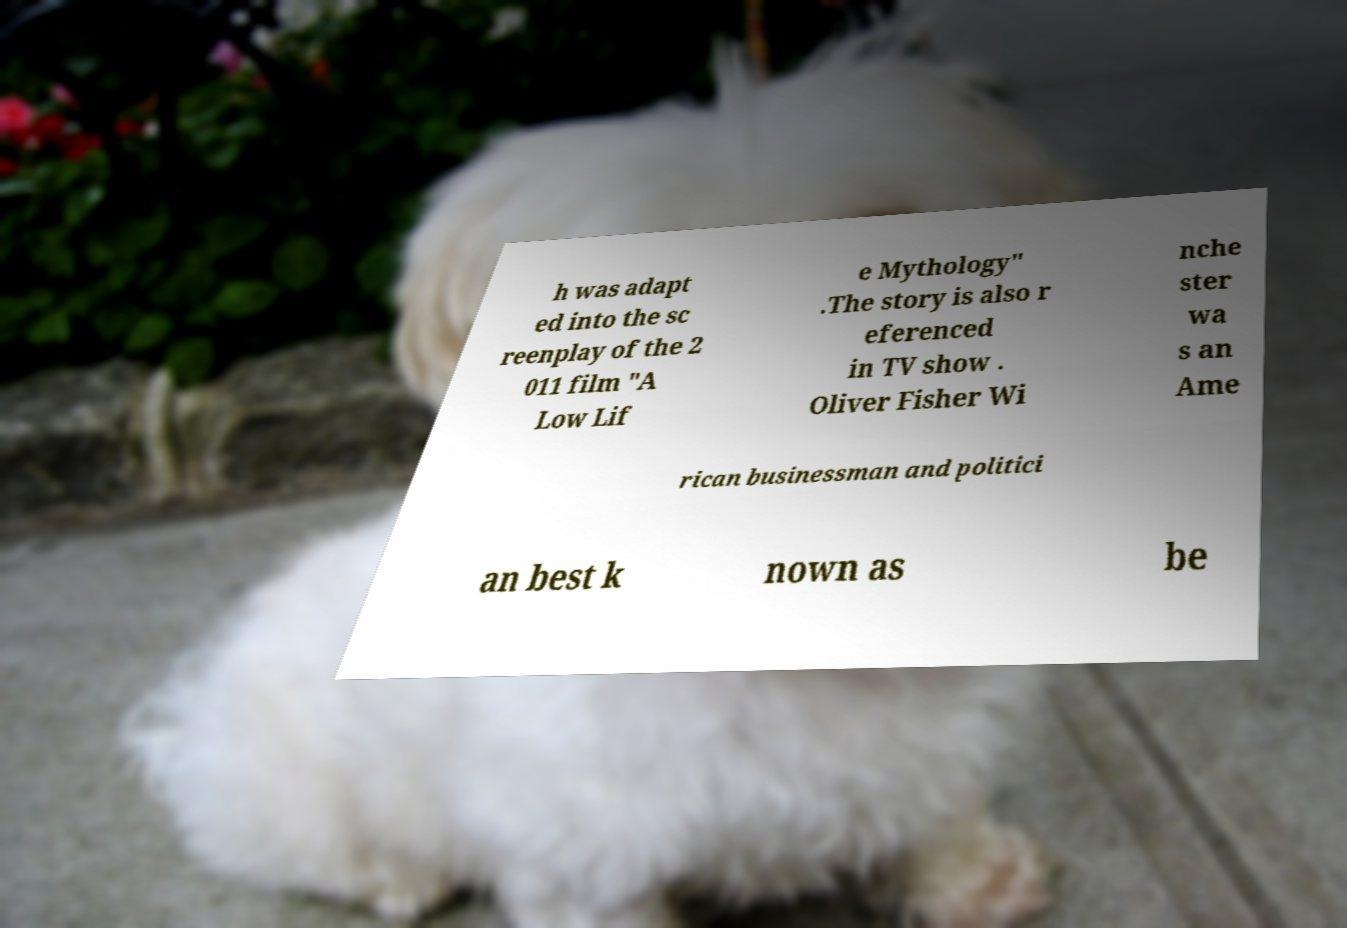What messages or text are displayed in this image? I need them in a readable, typed format. h was adapt ed into the sc reenplay of the 2 011 film "A Low Lif e Mythology" .The story is also r eferenced in TV show . Oliver Fisher Wi nche ster wa s an Ame rican businessman and politici an best k nown as be 